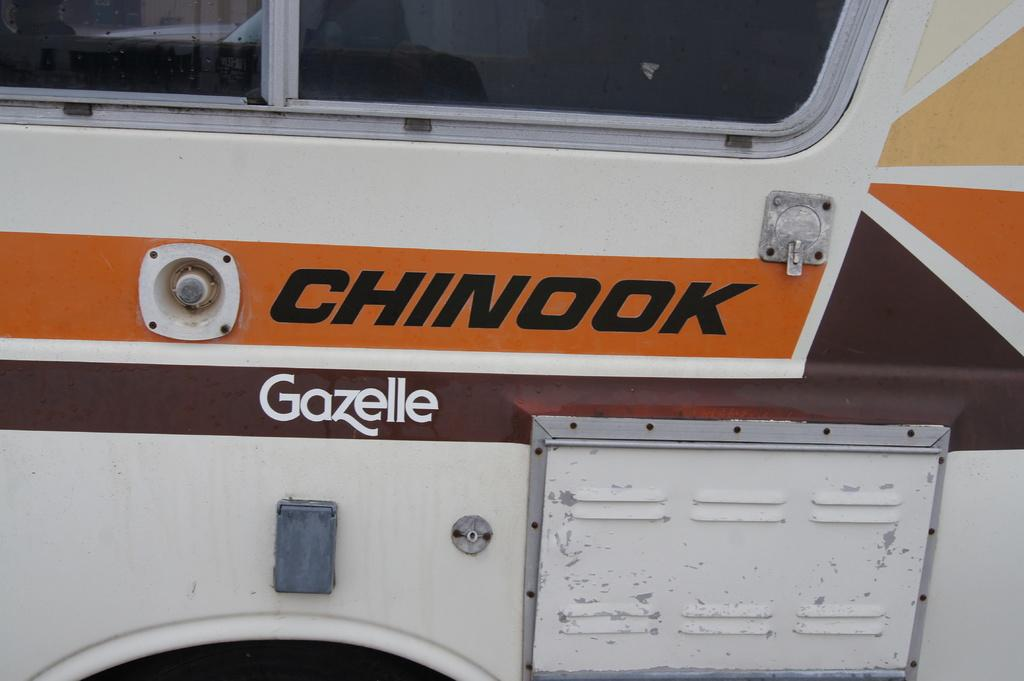What is the main object in the image? There is a vehicle in the image. What can be seen on the vehicle? There is text written on the vehicle. What type of architectural feature is present in the image? There is a glass door in the image. What type of quilt is draped over the vehicle in the image? There is no quilt present in the image; it features a vehicle with text on it and a glass door. Can you see a guitar being played near the vehicle in the image? There is no guitar or anyone playing it in the image. 